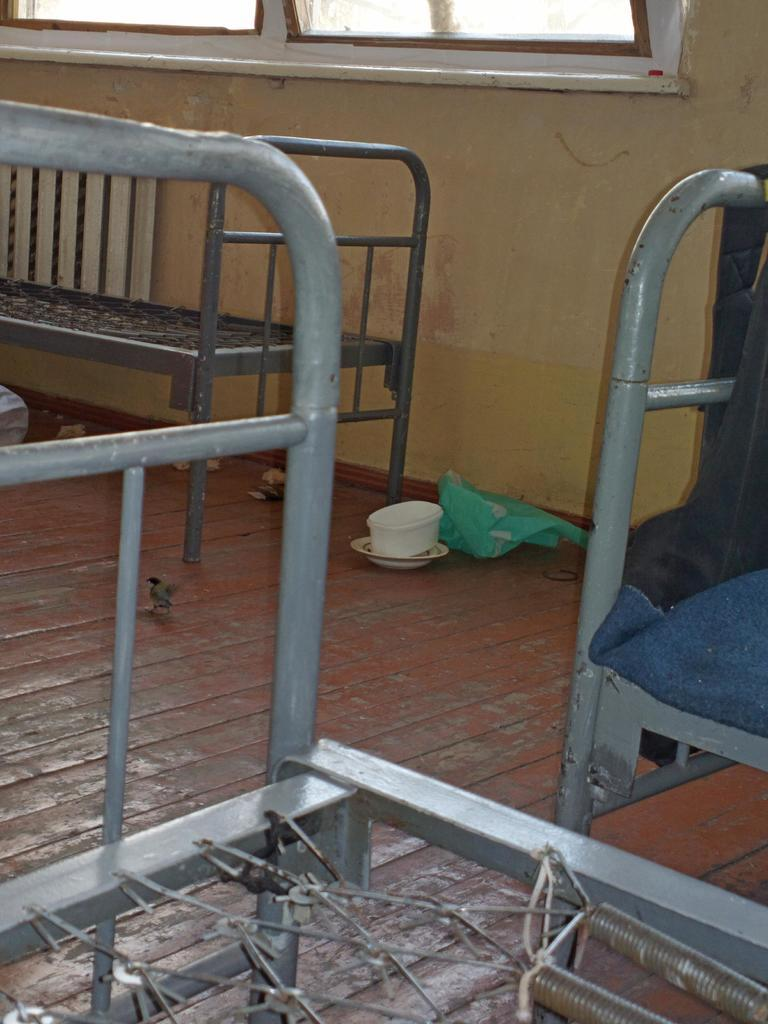What type of furniture is present in the image? There are metal beds in the image. What is on one of the beds? There are clothes on one of the beds. What else can be seen in the image besides the beds and clothes? There are objects in the image. What is on the floor in the image? There is a bird on the floor. What can be seen in the background of the image? There is a wall and a window in the background of the image. What type of pail is used to catch the bird in the image? There is no pail present in the image, and the bird is not being caught. 